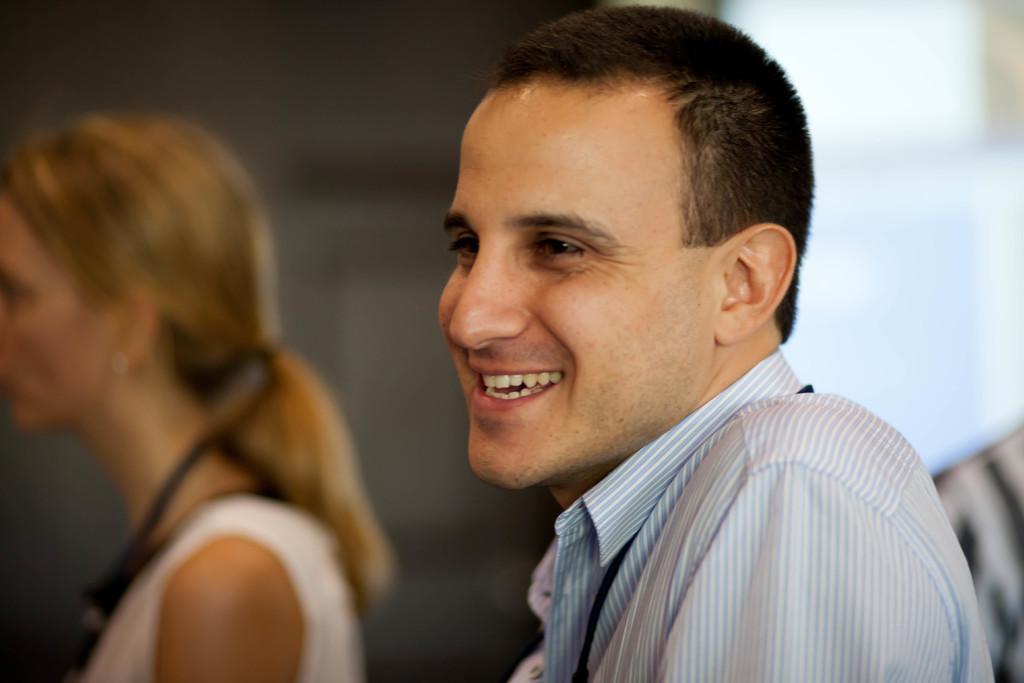Could you give a brief overview of what you see in this image? In this image we can see one person smiling. And besides, we can see some other people. 